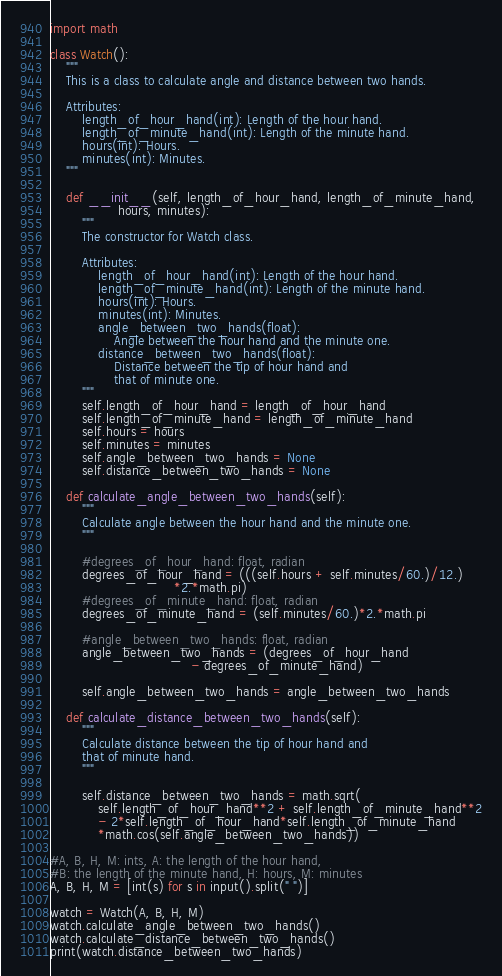Convert code to text. <code><loc_0><loc_0><loc_500><loc_500><_Python_>import math

class Watch():
    """
    This is a class to calculate angle and distance between two hands.
    
    Attributes:
        length_of_hour_hand(int): Length of the hour hand.
        length_of_minute_hand(int): Length of the minute hand.
        hours(int): Hours.
        minutes(int): Minutes.
    """

    def __init__(self, length_of_hour_hand, length_of_minute_hand,
                 hours, minutes):
        """
        The constructor for Watch class.

        Attributes:
            length_of_hour_hand(int): Length of the hour hand.
            length_of_minute_hand(int): Length of the minute hand.
            hours(int): Hours.
            minutes(int): Minutes.
            angle_between_two_hands(float): 
                Angle between the hour hand and the minute one.
            distance_between_two_hands(float): 
                Distance between the tip of hour hand and 
                that of minute one.
        """
        self.length_of_hour_hand = length_of_hour_hand
        self.length_of_minute_hand = length_of_minute_hand
        self.hours = hours
        self.minutes = minutes
        self.angle_between_two_hands = None
        self.distance_between_two_hands = None

    def calculate_angle_between_two_hands(self):
        """
        Calculate angle between the hour hand and the minute one.
        """

        #degrees_of_hour_hand: float, radian
        degrees_of_hour_hand = (((self.hours + self.minutes/60.)/12.)
                               *2.*math.pi)
        #degrees_of_minute_hand: float, radian
        degrees_of_minute_hand = (self.minutes/60.)*2.*math.pi
        
        #angle_between_two_hands: float, radian
        angle_between_two_hands = (degrees_of_hour_hand
                                   - degrees_of_minute_hand)
        
        self.angle_between_two_hands = angle_between_two_hands
    
    def calculate_distance_between_two_hands(self):
        """
        Calculate distance between the tip of hour hand and 
        that of minute hand.
        """                          

        self.distance_between_two_hands = math.sqrt(
            self.length_of_hour_hand**2 + self.length_of_minute_hand**2
            - 2*self.length_of_hour_hand*self.length_of_minute_hand
            *math.cos(self.angle_between_two_hands))

#A, B, H, M: ints, A: the length of the hour hand, 
#B: the length of the minute hand, H: hours, M: minutes
A, B, H, M = [int(s) for s in input().split(" ")] 

watch = Watch(A, B, H, M)
watch.calculate_angle_between_two_hands()
watch.calculate_distance_between_two_hands()
print(watch.distance_between_two_hands)</code> 